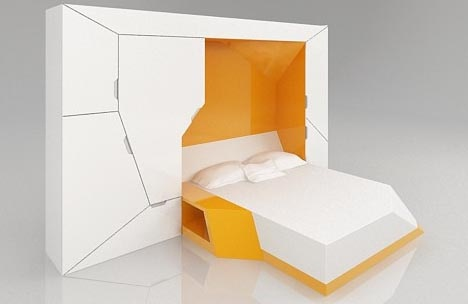Describe the objects in this image and their specific colors. I can see a bed in darkgray, lightgray, orange, and tan tones in this image. 